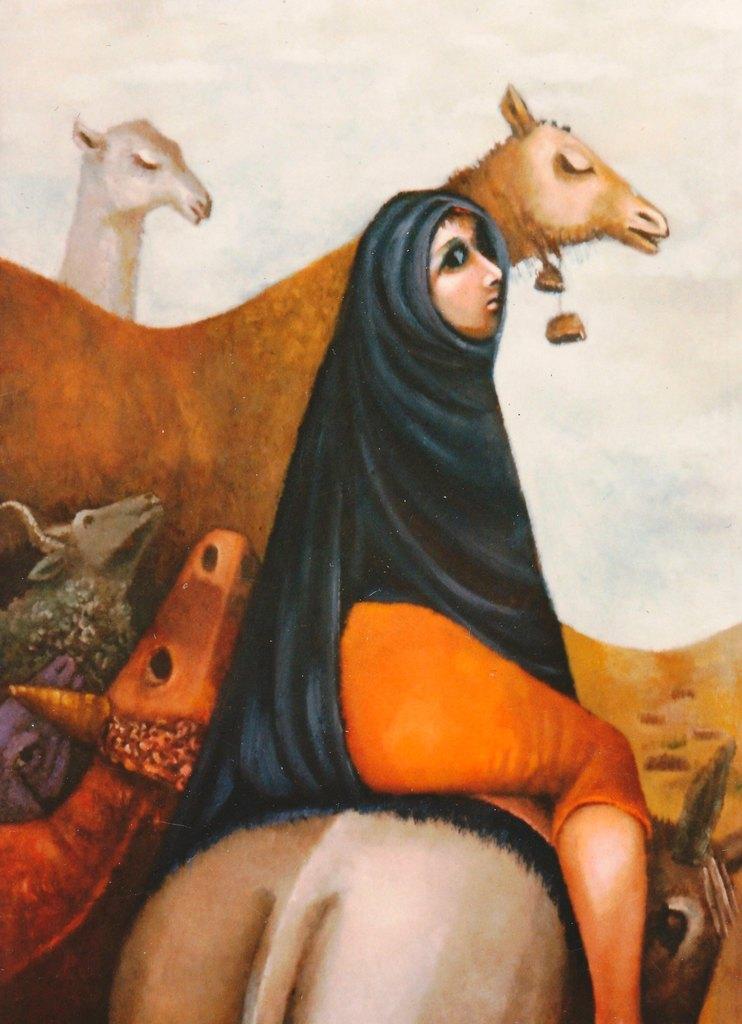In one or two sentences, can you explain what this image depicts? In this image we can see a picture in which there are animals and a woman. 